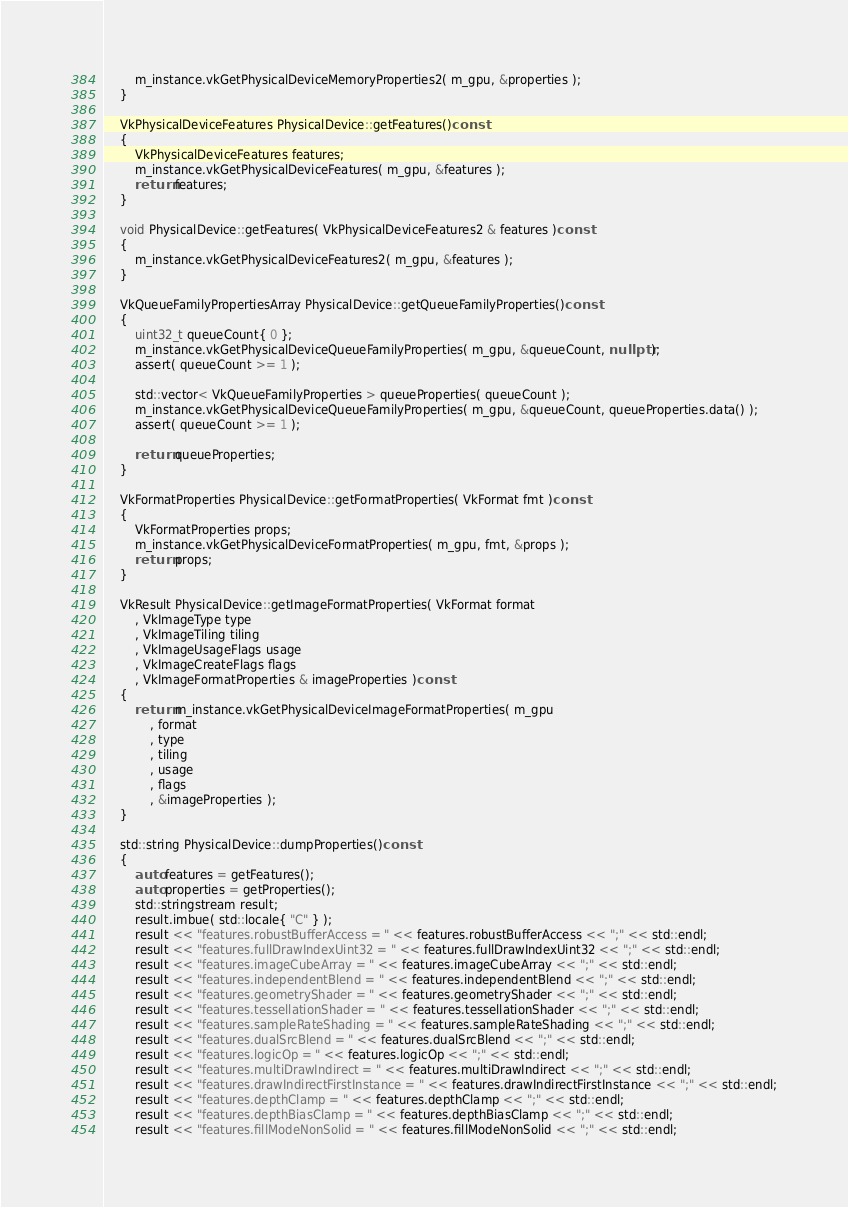Convert code to text. <code><loc_0><loc_0><loc_500><loc_500><_C++_>		m_instance.vkGetPhysicalDeviceMemoryProperties2( m_gpu, &properties );
	}

	VkPhysicalDeviceFeatures PhysicalDevice::getFeatures()const
	{
		VkPhysicalDeviceFeatures features;
		m_instance.vkGetPhysicalDeviceFeatures( m_gpu, &features );
		return features;
	}

	void PhysicalDevice::getFeatures( VkPhysicalDeviceFeatures2 & features )const
	{
		m_instance.vkGetPhysicalDeviceFeatures2( m_gpu, &features );
	}

	VkQueueFamilyPropertiesArray PhysicalDevice::getQueueFamilyProperties()const
	{
		uint32_t queueCount{ 0 };
		m_instance.vkGetPhysicalDeviceQueueFamilyProperties( m_gpu, &queueCount, nullptr );
		assert( queueCount >= 1 );

		std::vector< VkQueueFamilyProperties > queueProperties( queueCount );
		m_instance.vkGetPhysicalDeviceQueueFamilyProperties( m_gpu, &queueCount, queueProperties.data() );
		assert( queueCount >= 1 );

		return queueProperties;
	}

	VkFormatProperties PhysicalDevice::getFormatProperties( VkFormat fmt )const
	{
		VkFormatProperties props;
		m_instance.vkGetPhysicalDeviceFormatProperties( m_gpu, fmt, &props );
		return props;
	}

	VkResult PhysicalDevice::getImageFormatProperties( VkFormat format
		, VkImageType type
		, VkImageTiling tiling
		, VkImageUsageFlags usage
		, VkImageCreateFlags flags
		, VkImageFormatProperties & imageProperties )const
	{
		return m_instance.vkGetPhysicalDeviceImageFormatProperties( m_gpu
			, format
			, type
			, tiling
			, usage
			, flags
			, &imageProperties );
	}

	std::string PhysicalDevice::dumpProperties()const
	{
		auto features = getFeatures();
		auto properties = getProperties();
		std::stringstream result;
		result.imbue( std::locale{ "C" } );
		result << "features.robustBufferAccess = " << features.robustBufferAccess << ";" << std::endl;
		result << "features.fullDrawIndexUint32 = " << features.fullDrawIndexUint32 << ";" << std::endl;
		result << "features.imageCubeArray = " << features.imageCubeArray << ";" << std::endl;
		result << "features.independentBlend = " << features.independentBlend << ";" << std::endl;
		result << "features.geometryShader = " << features.geometryShader << ";" << std::endl;
		result << "features.tessellationShader = " << features.tessellationShader << ";" << std::endl;
		result << "features.sampleRateShading = " << features.sampleRateShading << ";" << std::endl;
		result << "features.dualSrcBlend = " << features.dualSrcBlend << ";" << std::endl;
		result << "features.logicOp = " << features.logicOp << ";" << std::endl;
		result << "features.multiDrawIndirect = " << features.multiDrawIndirect << ";" << std::endl;
		result << "features.drawIndirectFirstInstance = " << features.drawIndirectFirstInstance << ";" << std::endl;
		result << "features.depthClamp = " << features.depthClamp << ";" << std::endl;
		result << "features.depthBiasClamp = " << features.depthBiasClamp << ";" << std::endl;
		result << "features.fillModeNonSolid = " << features.fillModeNonSolid << ";" << std::endl;</code> 